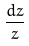<formula> <loc_0><loc_0><loc_500><loc_500>\frac { d z } { z }</formula> 